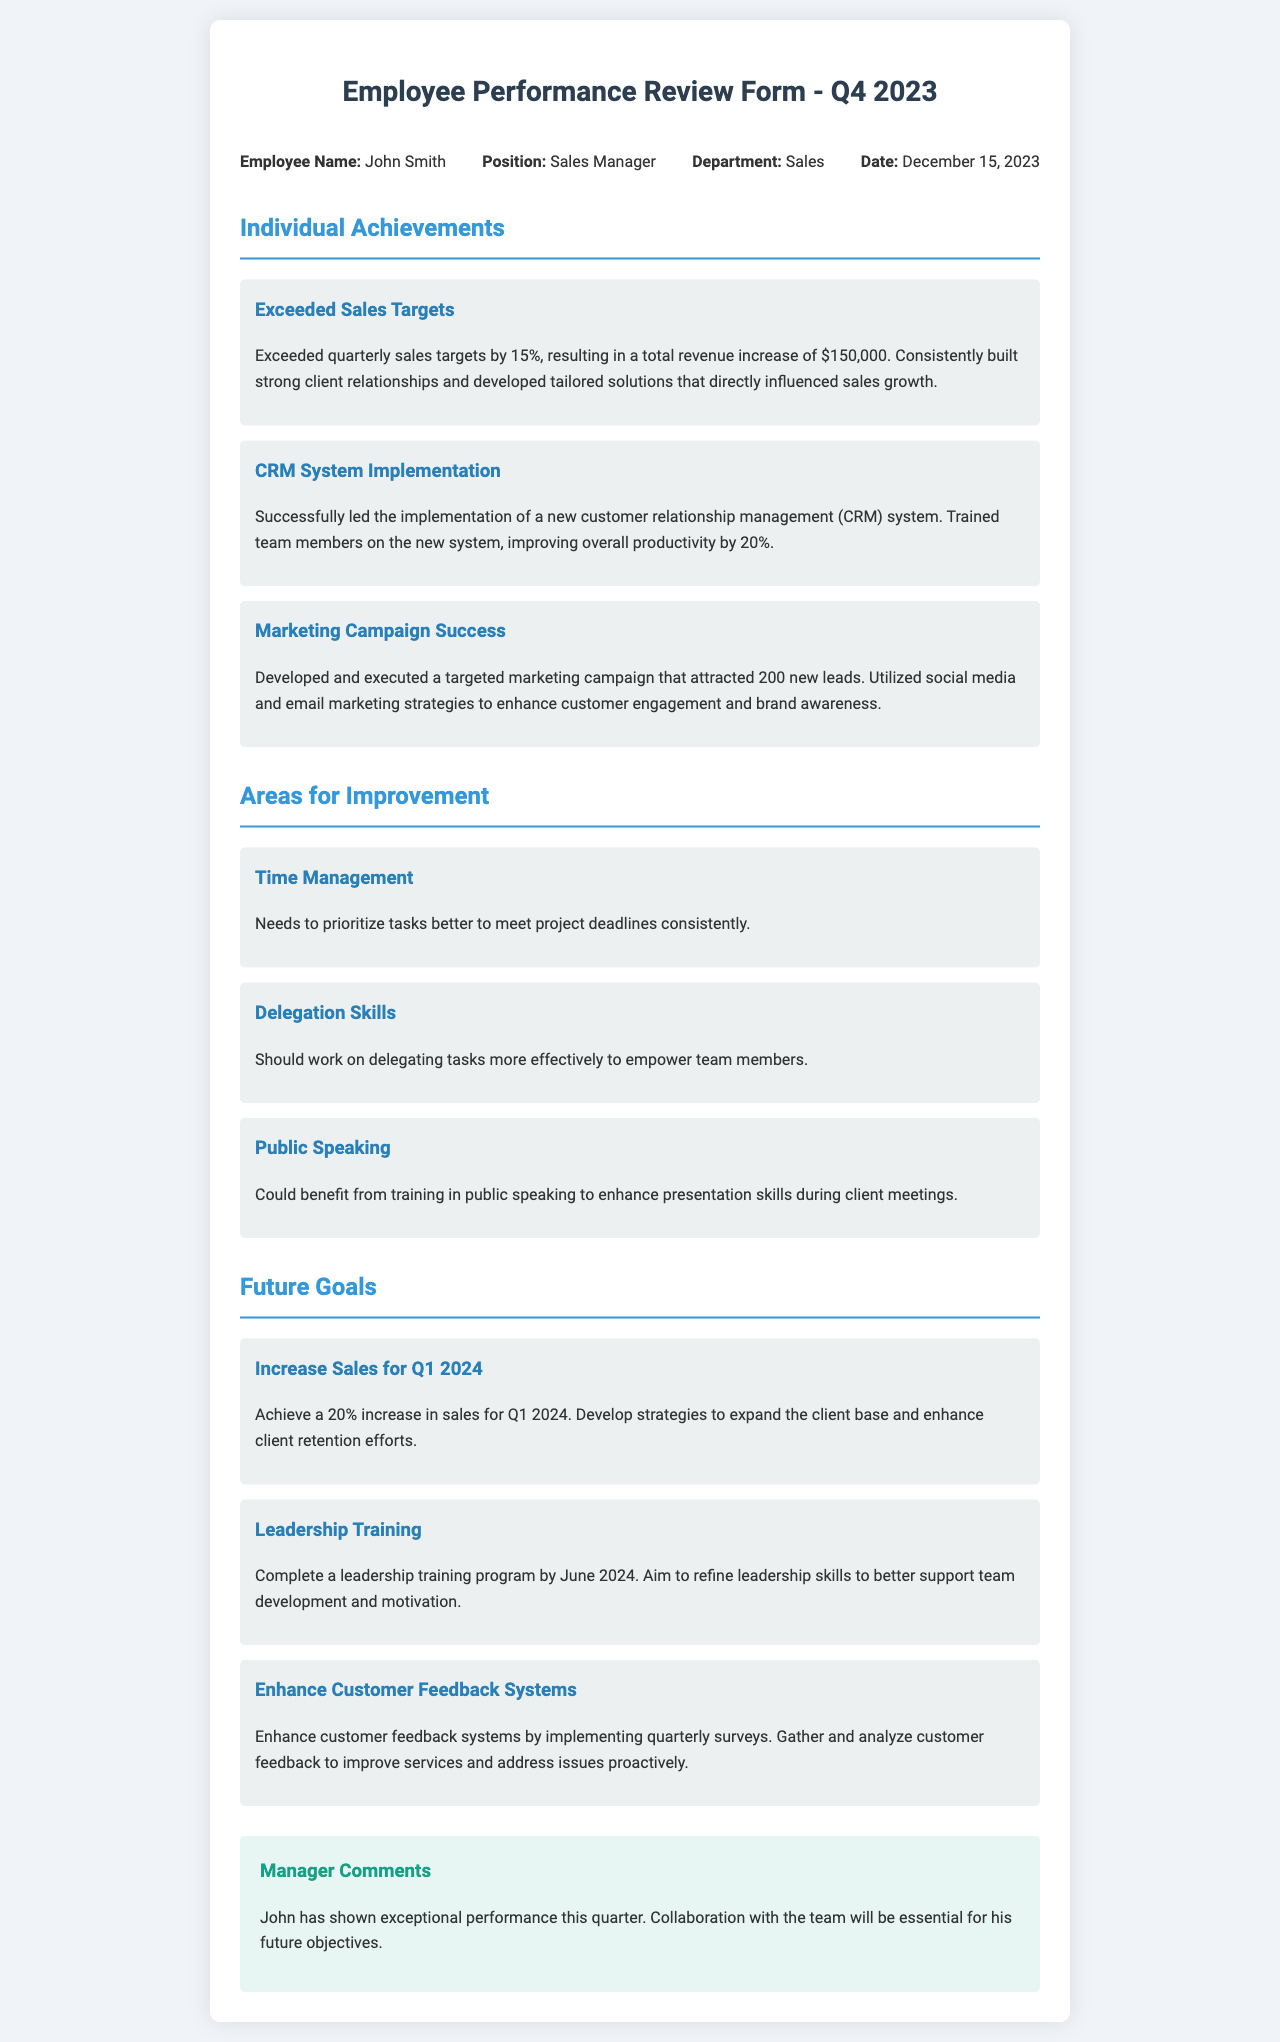What is the name of the employee? The employee's name is stated in the document under "Employee Name."
Answer: John Smith What position does the employee hold? The position is indicated under "Position" in the document.
Answer: Sales Manager What department is the employee a part of? The department is specified under "Department" in the document.
Answer: Sales When was the performance review conducted? The date of the performance review is mentioned in the "Date" section of the document.
Answer: December 15, 2023 What was the percentage by which sales targets were exceeded? This information is found in the "Individual Achievements" section regarding sales targets.
Answer: 15% What is one area for improvement mentioned in the document? The document lists areas for improvement; one of them is provided directly.
Answer: Time Management What is one future goal for the employee for Q1 2024? This can be found in the "Future Goals" section of the document.
Answer: 20% increase in sales What feedback is provided in the manager comments? The comments summarize the manager's assessment of the employee's performance.
Answer: Exceptional performance Which system did the employee successfully implement? The specific system is found in the achievements section of the document.
Answer: CRM System 